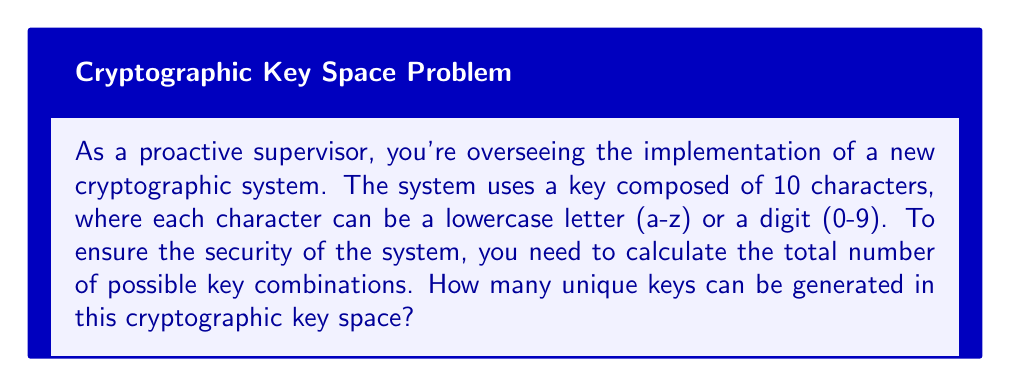Can you solve this math problem? Let's approach this step-by-step:

1. First, we need to determine the number of possible choices for each character position:
   - There are 26 lowercase letters (a-z)
   - There are 10 digits (0-9)
   - Total choices per character: 26 + 10 = 36

2. Now, we need to consider that we have 10 character positions, and for each position, we have 36 choices.

3. In cryptography, this scenario follows the multiplication principle. When we have independent events, we multiply the number of possibilities for each event.

4. Therefore, the total number of possible combinations is:

   $$ 36^{10} $$

5. To calculate this:
   $$ 36^{10} = 3,656,158,440,062,976 $$

This large number demonstrates the strength of the key space, which is crucial for cryptographic security.
Answer: $3,656,158,440,062,976$ 